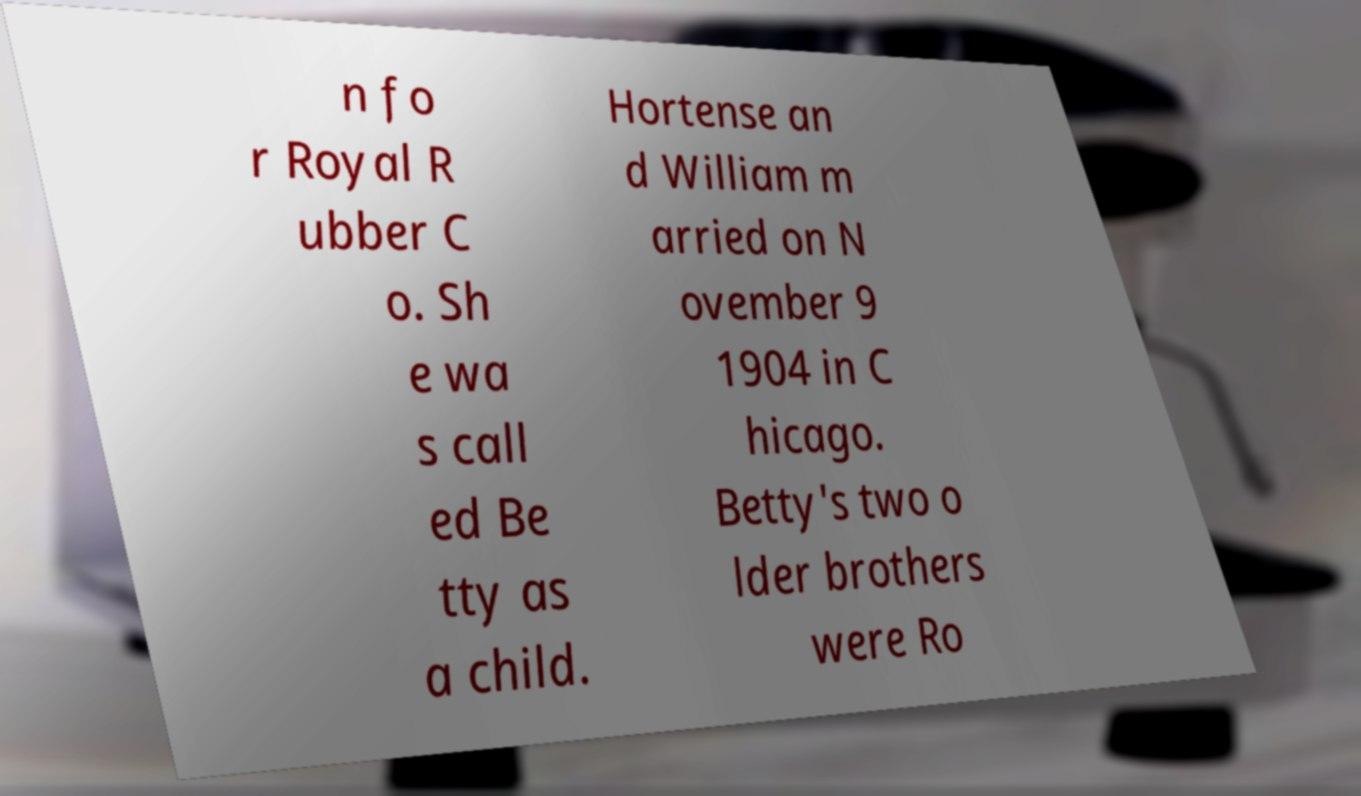Can you read and provide the text displayed in the image?This photo seems to have some interesting text. Can you extract and type it out for me? n fo r Royal R ubber C o. Sh e wa s call ed Be tty as a child. Hortense an d William m arried on N ovember 9 1904 in C hicago. Betty's two o lder brothers were Ro 